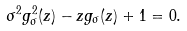<formula> <loc_0><loc_0><loc_500><loc_500>\sigma ^ { 2 } g _ { \sigma } ^ { 2 } ( z ) - z g _ { \sigma } ( z ) + 1 = 0 .</formula> 